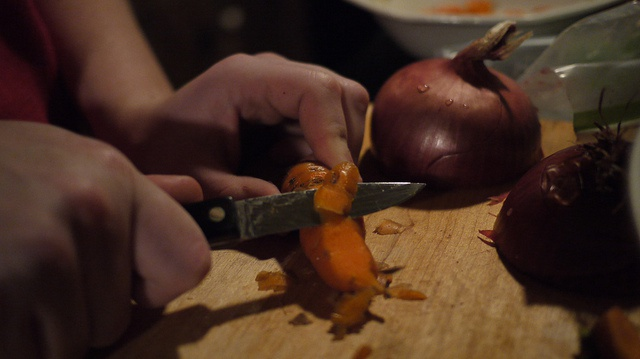Describe the objects in this image and their specific colors. I can see people in black, maroon, and brown tones, carrot in black, maroon, and brown tones, bowl in black and gray tones, and knife in black and gray tones in this image. 